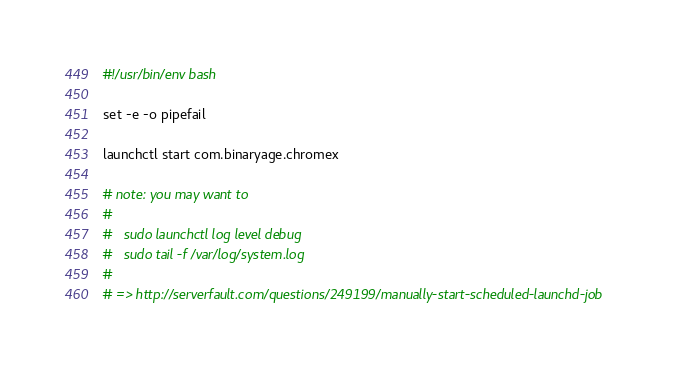Convert code to text. <code><loc_0><loc_0><loc_500><loc_500><_Bash_>#!/usr/bin/env bash

set -e -o pipefail

launchctl start com.binaryage.chromex

# note: you may want to
#
#   sudo launchctl log level debug
#   sudo tail -f /var/log/system.log
# 
# => http://serverfault.com/questions/249199/manually-start-scheduled-launchd-job
</code> 